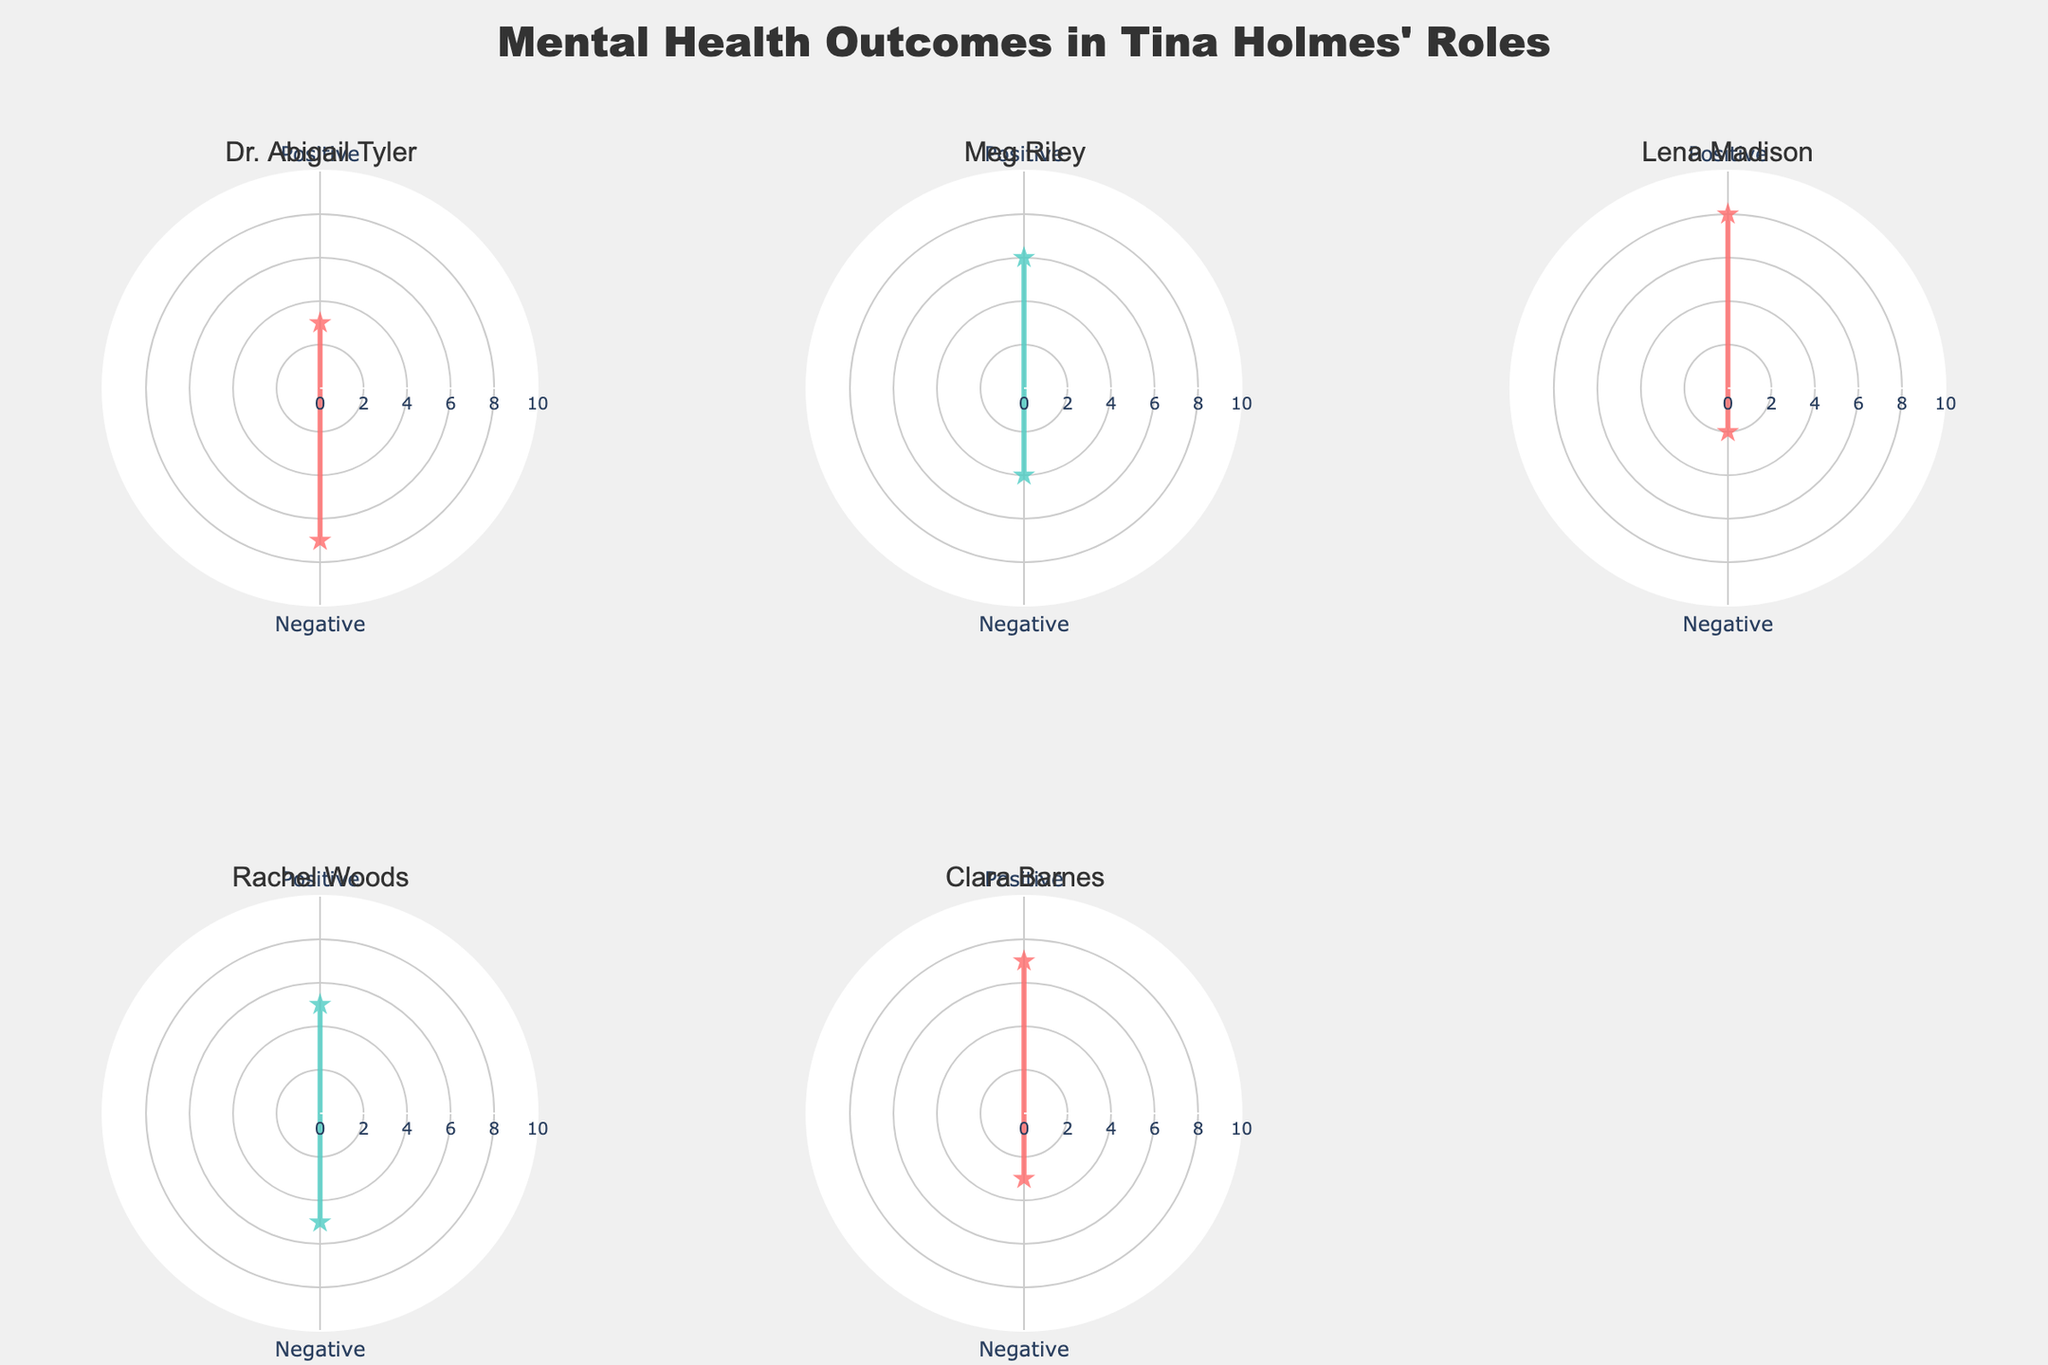What is the title of the chart? The title is located at the top of the figure in large, bold font.
Answer: Mental Health Outcomes in Tina Holmes' Roles Which role has the highest frequency of positive mental health outcomes? To find the role with the highest frequency of positive outcomes, compare the 'Positive' values for all roles.
Answer: Lena Madison How does the frequency of negative mental health outcomes for Dr. Abigail Tyler compare to that of Rachel Woods? Compare the angles labelled 'Negative' for both Dr. Abigail Tyler and Rachel Woods.
Answer: Higher for Dr. Abigail Tyler What is the total frequency of positive mental health outcomes across all roles? Sum the 'Positive' frequencies for all roles (3+6+8+5+7).
Answer: 29 Which role has the most balanced frequency between positive and negative mental health outcomes? The most balanced frequency would have the smallest difference between positive and negative frequencies.
Answer: Rachel Woods What is the range of the radial axis in the chart? The range is given in the description of the radial axis.
Answer: 0 to 10 Compare the positive mental health outcomes of Meg Riley and Clara Barnes. Who has more, and by how much? Subtract the frequency of positive outcomes for Meg Riley from Clara Barnes.
Answer: Clara Barnes by 1 Which role has the lowest frequency of negative mental health outcomes? Identify which role has the lowest value for 'Negative' frequencies.
Answer: Lena Madison What are the custom colors used in the chart? The visible colors in the chart, without referring to specific codes.
Answer: Red and Teal For the role of Clara Barnes, what is the ratio of positive to negative mental health outcomes? Divide the frequency of positive outcomes by the frequency of negative outcomes for Clara Barnes.
Answer: 7:3 